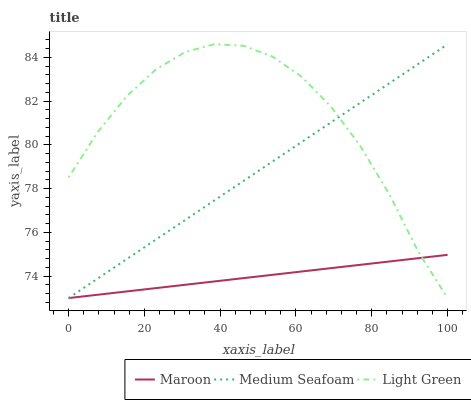Does Maroon have the minimum area under the curve?
Answer yes or no. Yes. Does Light Green have the maximum area under the curve?
Answer yes or no. Yes. Does Medium Seafoam have the minimum area under the curve?
Answer yes or no. No. Does Medium Seafoam have the maximum area under the curve?
Answer yes or no. No. Is Medium Seafoam the smoothest?
Answer yes or no. Yes. Is Light Green the roughest?
Answer yes or no. Yes. Is Maroon the smoothest?
Answer yes or no. No. Is Maroon the roughest?
Answer yes or no. No. Does Light Green have the highest value?
Answer yes or no. Yes. Does Medium Seafoam have the highest value?
Answer yes or no. No. Does Light Green intersect Maroon?
Answer yes or no. Yes. Is Light Green less than Maroon?
Answer yes or no. No. Is Light Green greater than Maroon?
Answer yes or no. No. 